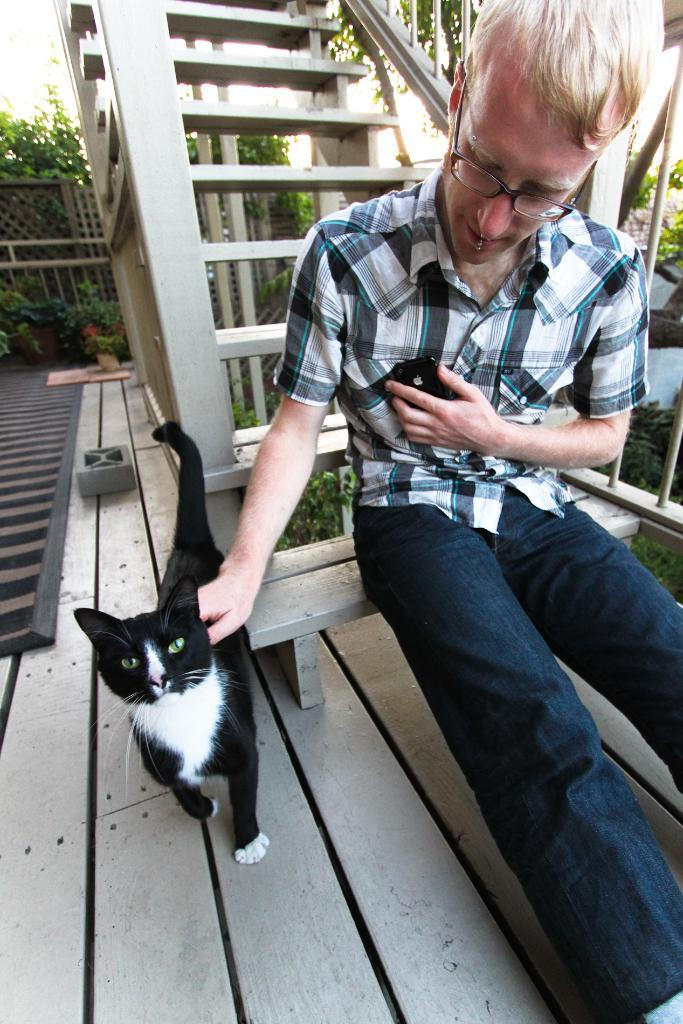What is the person in the image doing? The person is sitting on a staircase. Can you describe the person's appearance? The person is wearing a spectacle. What is the person holding in their hand? The person is holding a mobile. What type of animal is the person holding? The person is holding a cat. What can be seen in the background of the image? There are steps, trees, and a fence visible in the background. How many cakes are being served to the cows in the image? There are no cakes or cows present in the image. Can you describe the tiger's behavior in the image? There is no tiger present in the image. 